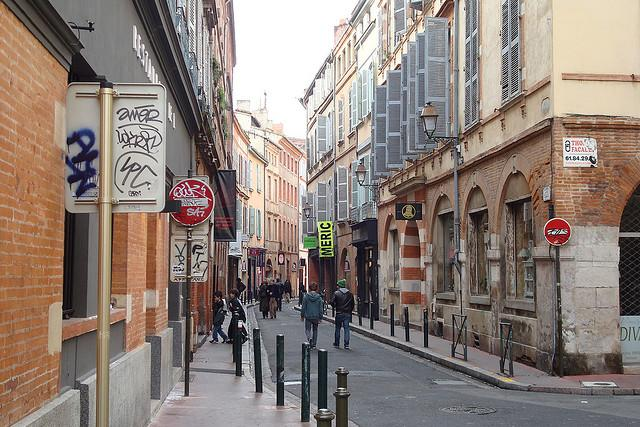What damage has been done in this street?

Choices:
A) cracked ground
B) illegal construction
C) graffiti
D) arson graffiti 